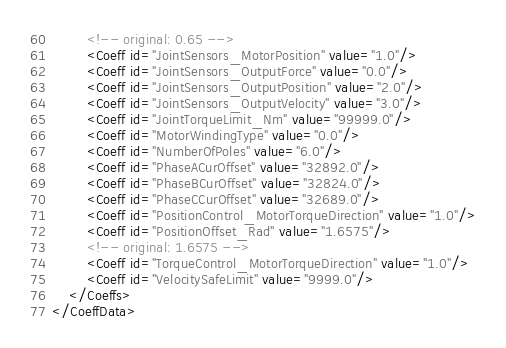<code> <loc_0><loc_0><loc_500><loc_500><_XML_>        <!-- original: 0.65 -->
        <Coeff id="JointSensors_MotorPosition" value="1.0"/>
        <Coeff id="JointSensors_OutputForce" value="0.0"/>
        <Coeff id="JointSensors_OutputPosition" value="2.0"/>
        <Coeff id="JointSensors_OutputVelocity" value="3.0"/>
        <Coeff id="JointTorqueLimit_Nm" value="99999.0"/>
        <Coeff id="MotorWindingType" value="0.0"/>
        <Coeff id="NumberOfPoles" value="6.0"/>
        <Coeff id="PhaseACurOffset" value="32892.0"/>
        <Coeff id="PhaseBCurOffset" value="32824.0"/>
        <Coeff id="PhaseCCurOffset" value="32689.0"/>
        <Coeff id="PositionControl_MotorTorqueDirection" value="1.0"/>
        <Coeff id="PositionOffset_Rad" value="1.6575"/>
        <!-- original: 1.6575 -->
        <Coeff id="TorqueControl_MotorTorqueDirection" value="1.0"/>
        <Coeff id="VelocitySafeLimit" value="9999.0"/>
    </Coeffs>
</CoeffData></code> 